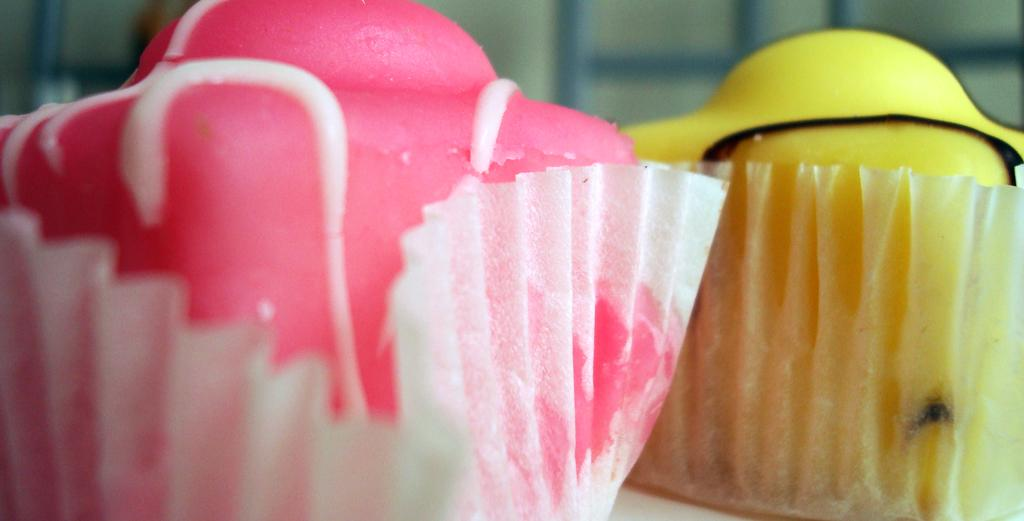What is the main subject of the image? The main subject of the image is two cupcakes. Can you describe the appearance of the cupcakes? One cupcake is pink, and the other is yellow. What can be seen in the background of the image? There is a wall and a few other objects in the background of the image. What type of polish is being applied to the cupcakes in the image? There is no polish being applied to the cupcakes in the image; they are simply sitting on a surface. How do the cupcakes make you feel when you look at them? The image does not convey any feelings or emotions, as it is a static representation of the cupcakes. 